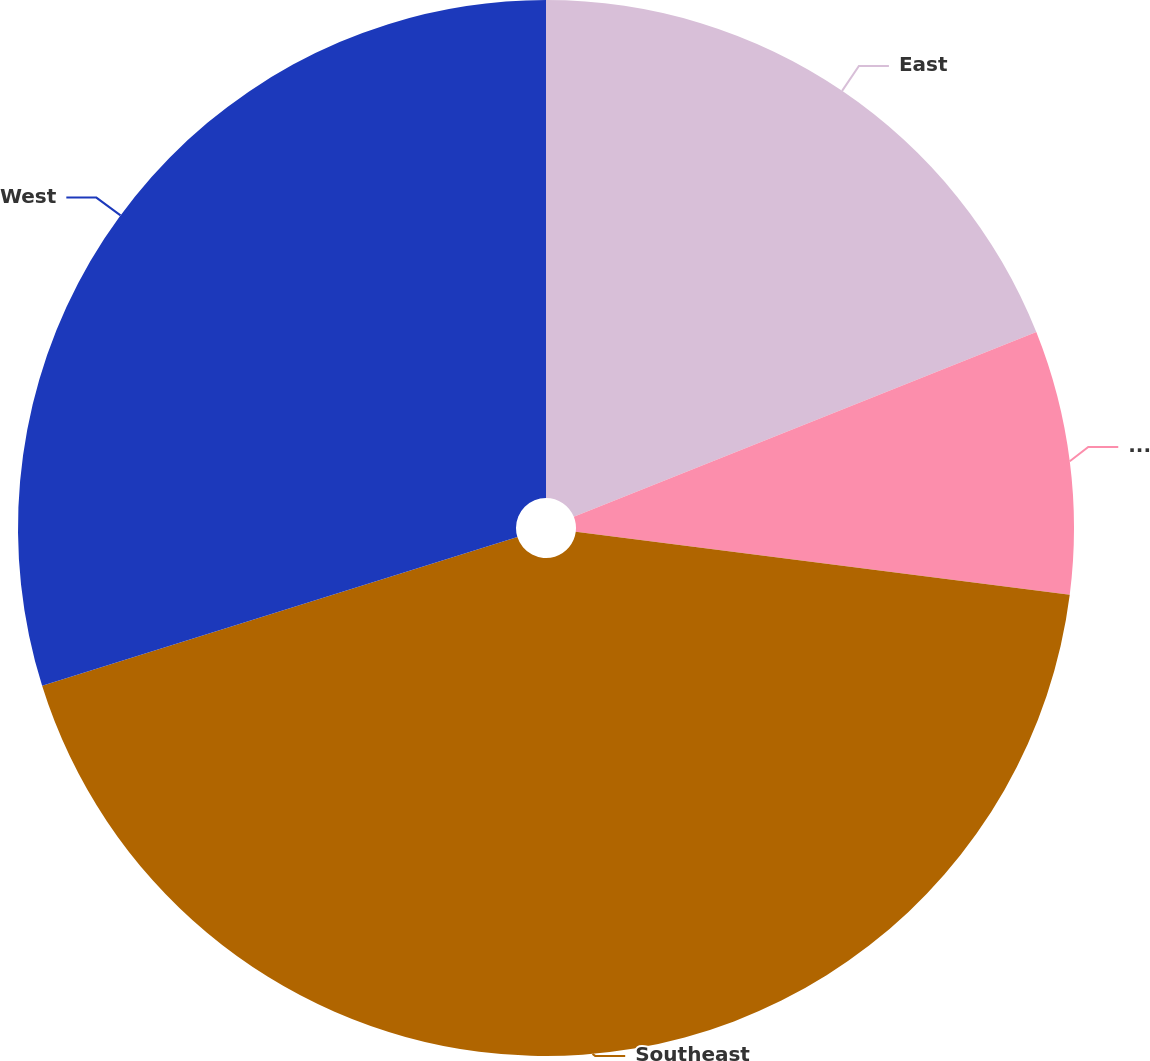Convert chart to OTSL. <chart><loc_0><loc_0><loc_500><loc_500><pie_chart><fcel>East<fcel>Midwest<fcel>Southeast<fcel>West<nl><fcel>18.95%<fcel>8.07%<fcel>43.15%<fcel>29.83%<nl></chart> 